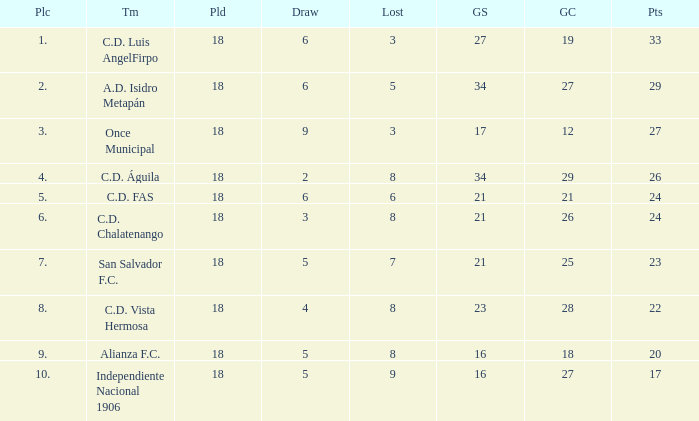How many points were in a game that had a lost of 5, greater than place 2, and 27 goals conceded? 0.0. 